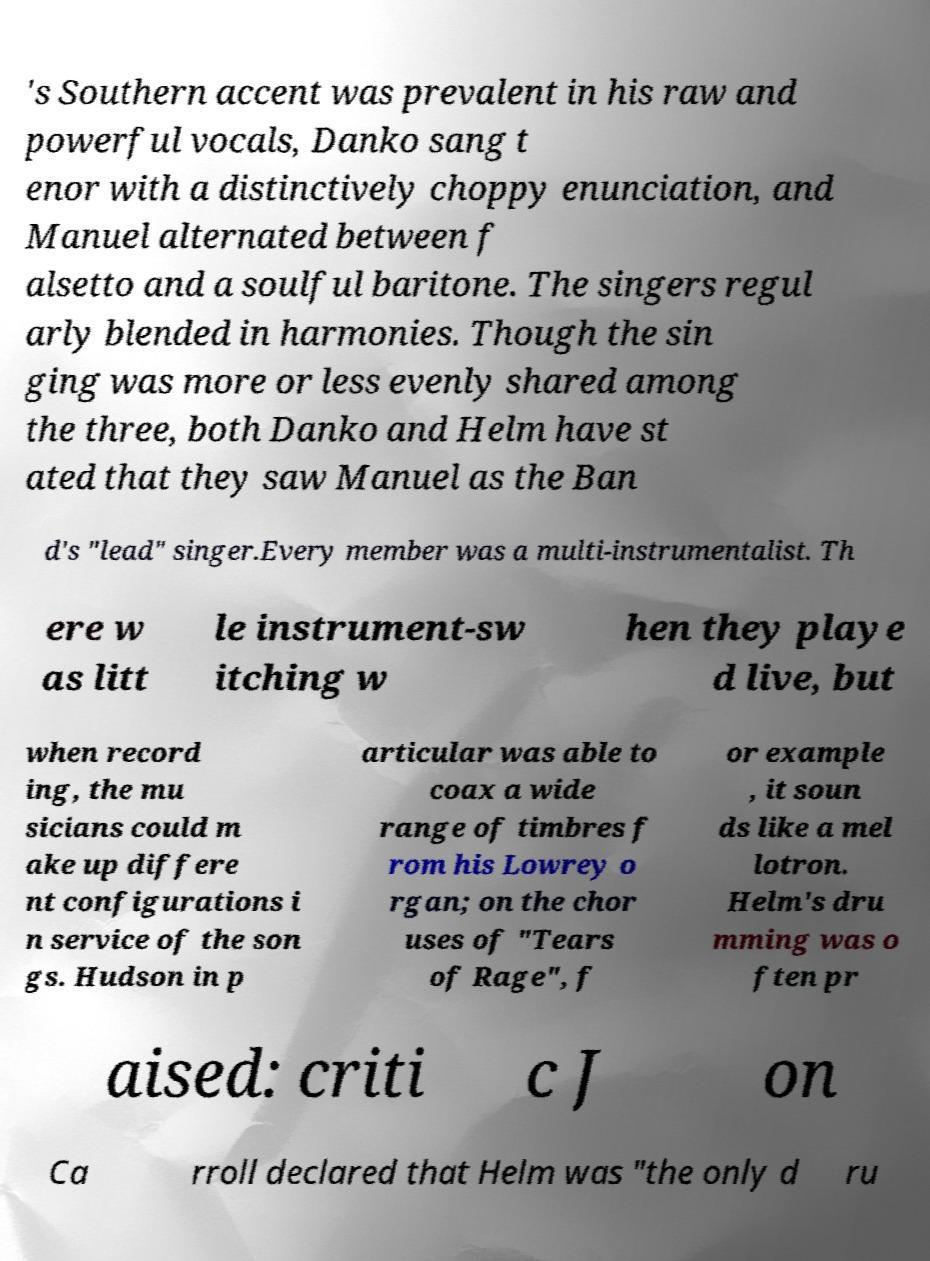Can you accurately transcribe the text from the provided image for me? 's Southern accent was prevalent in his raw and powerful vocals, Danko sang t enor with a distinctively choppy enunciation, and Manuel alternated between f alsetto and a soulful baritone. The singers regul arly blended in harmonies. Though the sin ging was more or less evenly shared among the three, both Danko and Helm have st ated that they saw Manuel as the Ban d's "lead" singer.Every member was a multi-instrumentalist. Th ere w as litt le instrument-sw itching w hen they playe d live, but when record ing, the mu sicians could m ake up differe nt configurations i n service of the son gs. Hudson in p articular was able to coax a wide range of timbres f rom his Lowrey o rgan; on the chor uses of "Tears of Rage", f or example , it soun ds like a mel lotron. Helm's dru mming was o ften pr aised: criti c J on Ca rroll declared that Helm was "the only d ru 